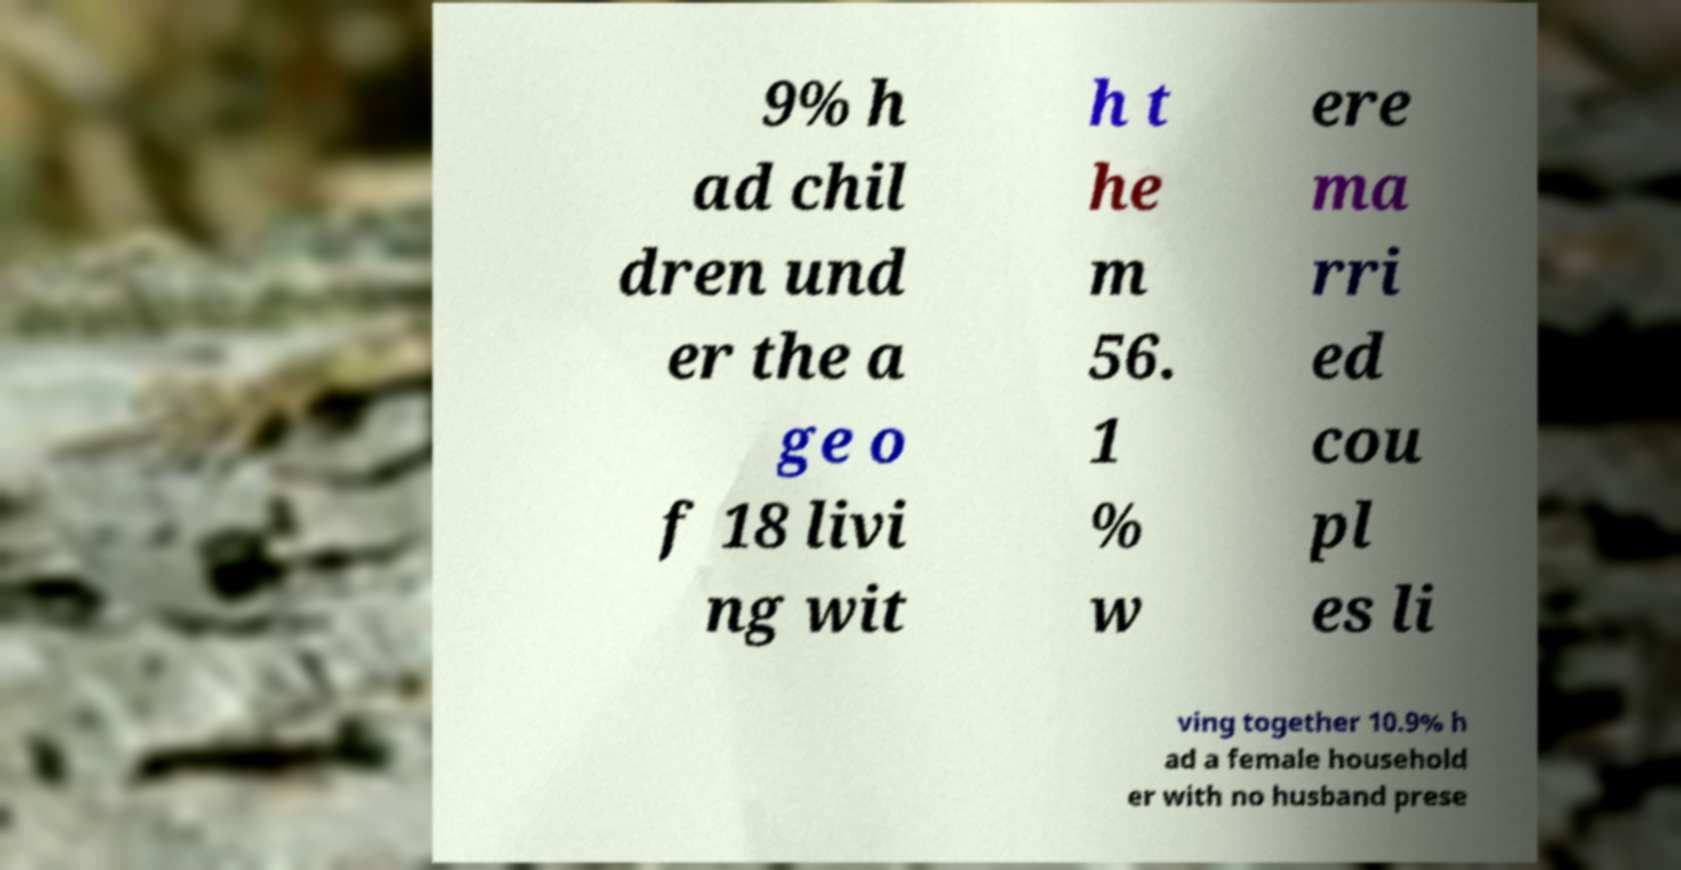Please identify and transcribe the text found in this image. 9% h ad chil dren und er the a ge o f 18 livi ng wit h t he m 56. 1 % w ere ma rri ed cou pl es li ving together 10.9% h ad a female household er with no husband prese 